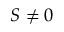Convert formula to latex. <formula><loc_0><loc_0><loc_500><loc_500>S \ne 0</formula> 